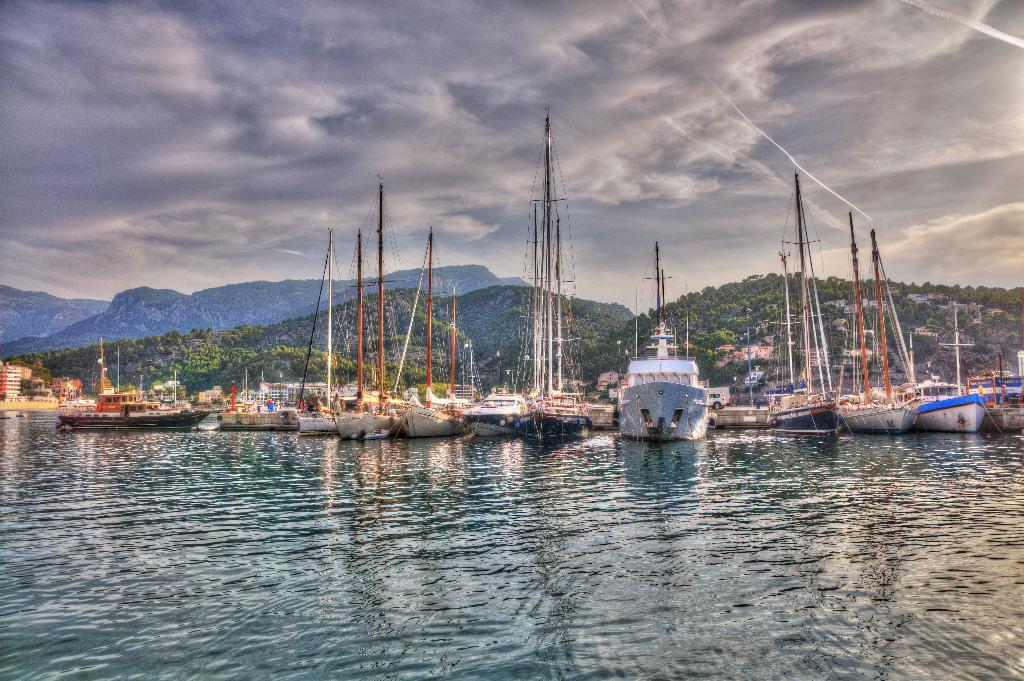What is located on the water in the image? There is a fleet on the water in the image. What can be seen in the image besides the fleet? There are poles, trees, hills, and the sky visible in the image. What type of vegetation is in the background of the image? There are trees in the background of the image. What geographical feature is visible in the background of the image? There are hills in the background of the image. What is visible in the sky in the image? The sky is visible in the image, and there are clouds in the sky. What position: What position does the dad hold in the image? There is no dad present in the image, so it is not possible to determine his position. 